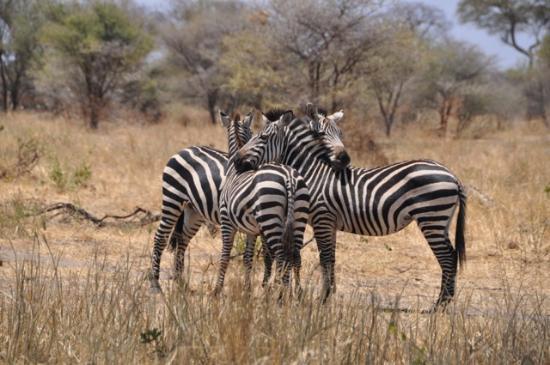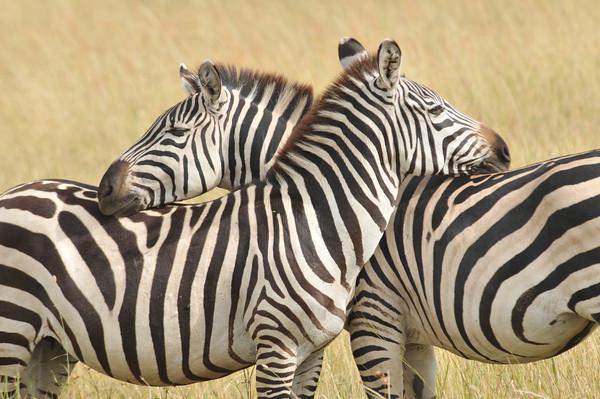The first image is the image on the left, the second image is the image on the right. For the images displayed, is the sentence "Each image shows at least two zebra standing facing toward the center, one with its head over the back of the other." factually correct? Answer yes or no. Yes. 